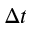Convert formula to latex. <formula><loc_0><loc_0><loc_500><loc_500>\Delta t</formula> 